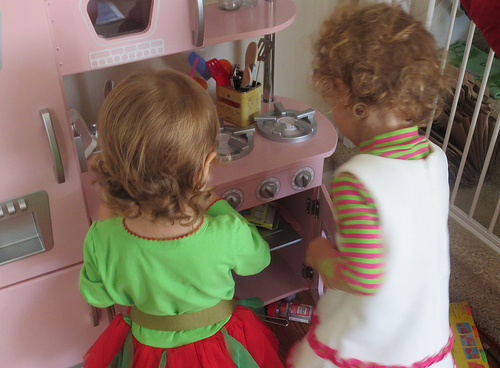<image>
Is the play stove above the real spices? Yes. The play stove is positioned above the real spices in the vertical space, higher up in the scene. 